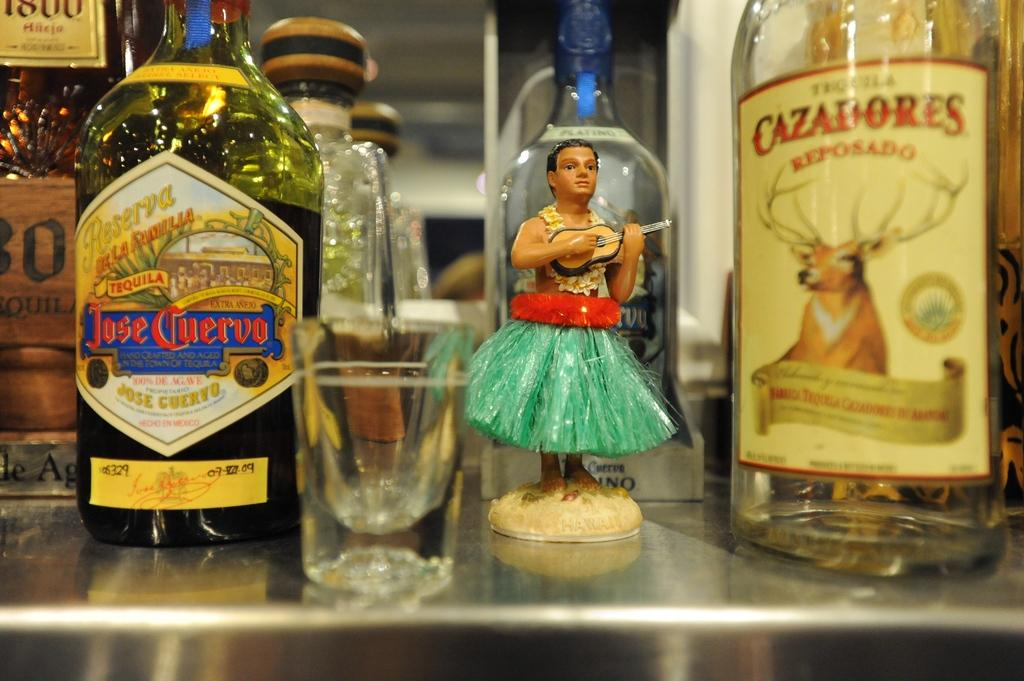What type of containers can be seen in the image? There are glass bottles and a tumbler in the image. What else is present in the image besides the containers? There is a toy in the image. Where are the containers placed? The objects are placed on a table. How are the glass bottles sealed? The glass bottles are closed with cockpits. How many cars can be seen driving on the table in the image? There are no cars present in the image, and the objects are placed on a table, not driven on it. 